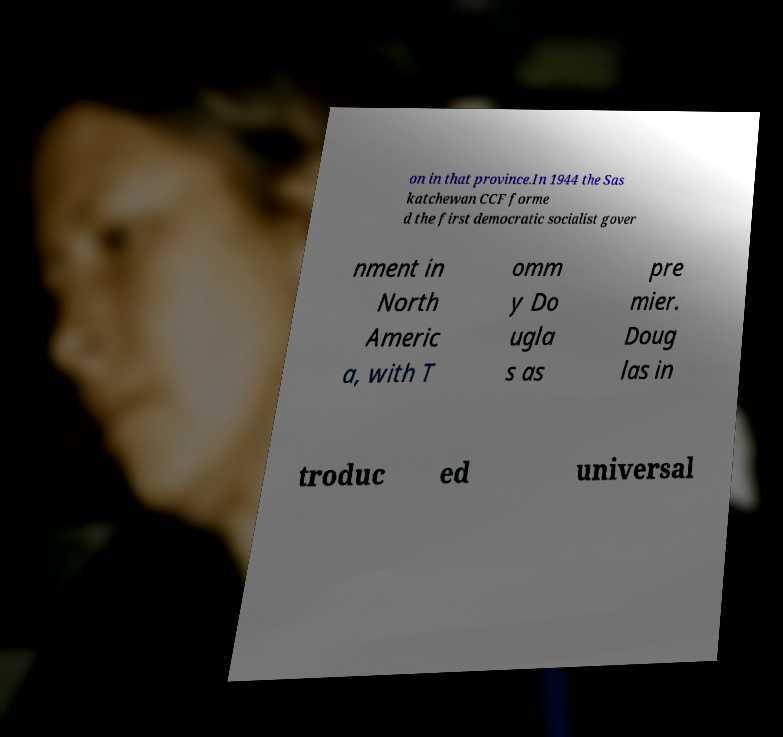There's text embedded in this image that I need extracted. Can you transcribe it verbatim? on in that province.In 1944 the Sas katchewan CCF forme d the first democratic socialist gover nment in North Americ a, with T omm y Do ugla s as pre mier. Doug las in troduc ed universal 